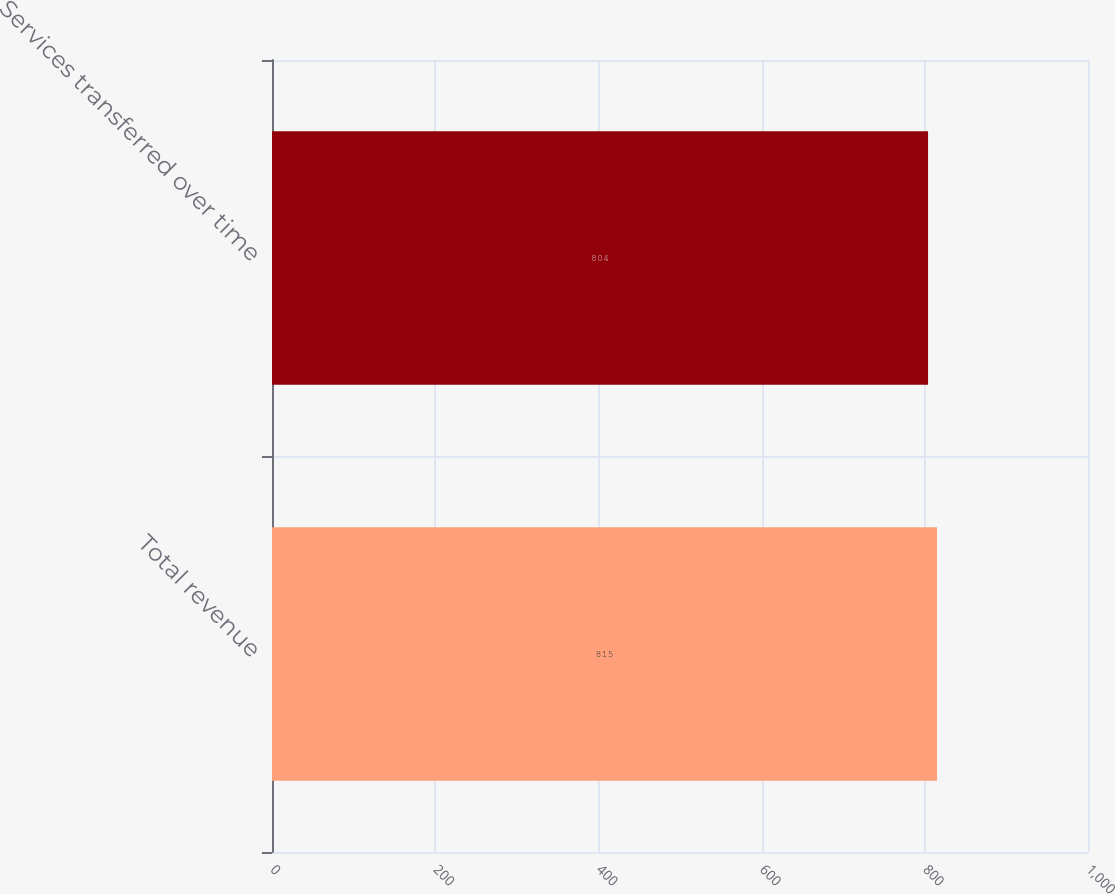<chart> <loc_0><loc_0><loc_500><loc_500><bar_chart><fcel>Total revenue<fcel>Services transferred over time<nl><fcel>815<fcel>804<nl></chart> 